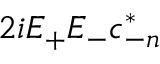<formula> <loc_0><loc_0><loc_500><loc_500>2 i E _ { + } E _ { - } c _ { - n } ^ { \ast }</formula> 